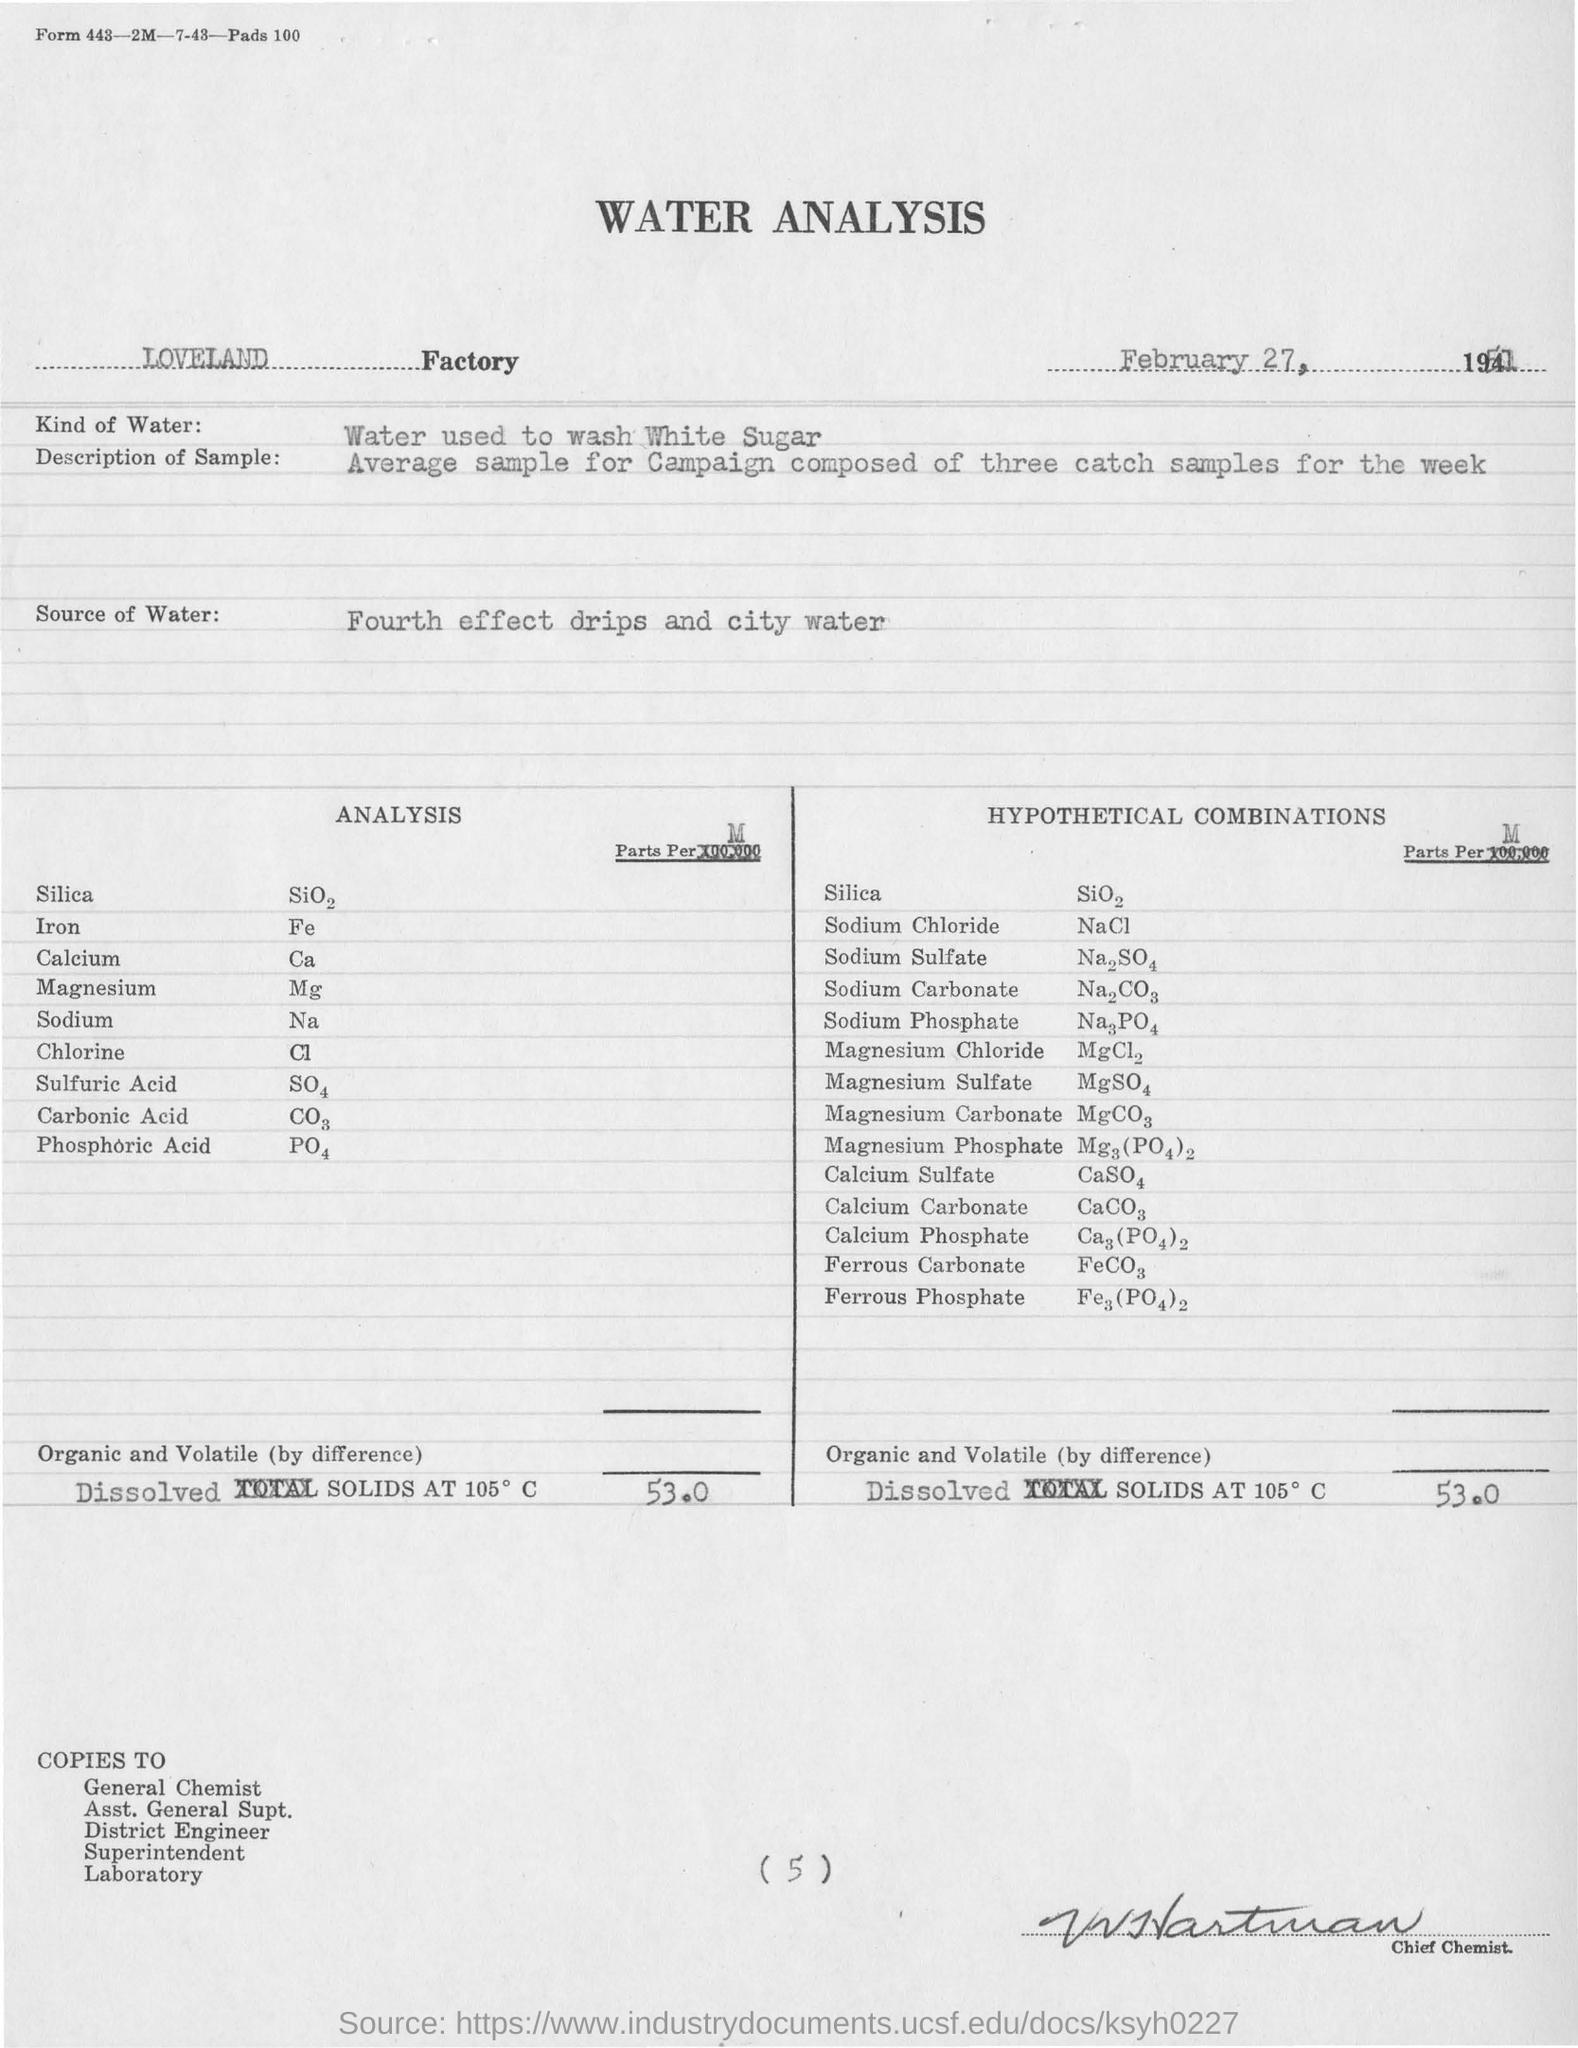Identify some key points in this picture. The document mentions a factory called LOVELAND Factory. The source of water is the fourth effect of drips and city water. 